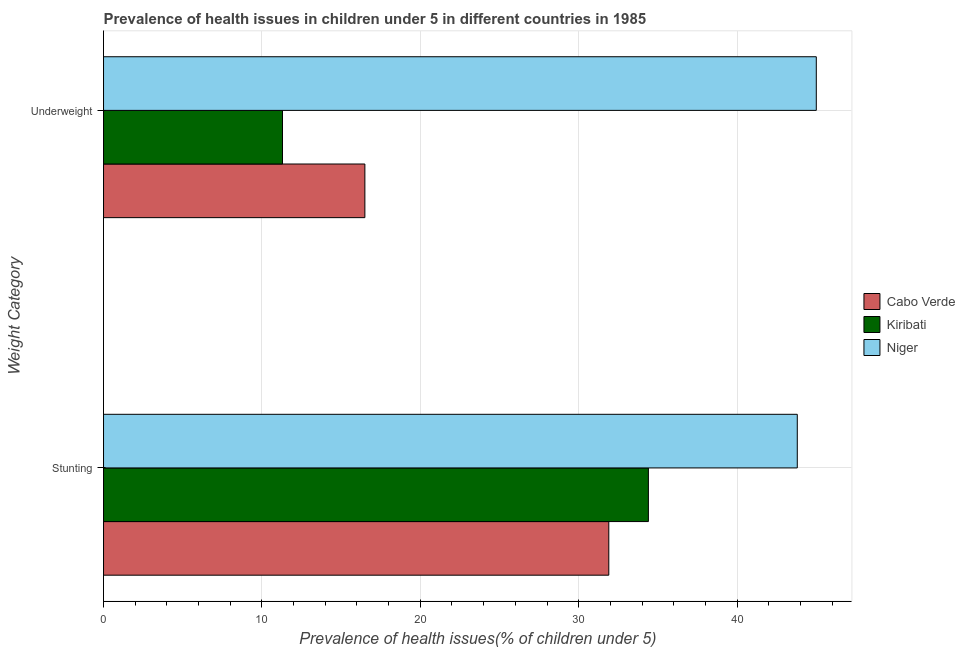How many different coloured bars are there?
Keep it short and to the point. 3. Are the number of bars per tick equal to the number of legend labels?
Your answer should be very brief. Yes. What is the label of the 1st group of bars from the top?
Offer a terse response. Underweight. What is the percentage of stunted children in Niger?
Ensure brevity in your answer.  43.8. Across all countries, what is the minimum percentage of underweight children?
Make the answer very short. 11.3. In which country was the percentage of underweight children maximum?
Ensure brevity in your answer.  Niger. In which country was the percentage of underweight children minimum?
Your response must be concise. Kiribati. What is the total percentage of stunted children in the graph?
Offer a very short reply. 110.1. What is the difference between the percentage of stunted children in Niger and the percentage of underweight children in Cabo Verde?
Your response must be concise. 27.3. What is the average percentage of stunted children per country?
Provide a short and direct response. 36.7. What is the difference between the percentage of underweight children and percentage of stunted children in Niger?
Make the answer very short. 1.2. What is the ratio of the percentage of underweight children in Cabo Verde to that in Niger?
Ensure brevity in your answer.  0.37. In how many countries, is the percentage of stunted children greater than the average percentage of stunted children taken over all countries?
Make the answer very short. 1. What does the 3rd bar from the top in Underweight represents?
Keep it short and to the point. Cabo Verde. What does the 2nd bar from the bottom in Underweight represents?
Offer a terse response. Kiribati. How many bars are there?
Offer a terse response. 6. Does the graph contain grids?
Provide a short and direct response. Yes. Where does the legend appear in the graph?
Your response must be concise. Center right. How many legend labels are there?
Offer a very short reply. 3. How are the legend labels stacked?
Offer a very short reply. Vertical. What is the title of the graph?
Ensure brevity in your answer.  Prevalence of health issues in children under 5 in different countries in 1985. What is the label or title of the X-axis?
Offer a very short reply. Prevalence of health issues(% of children under 5). What is the label or title of the Y-axis?
Provide a succinct answer. Weight Category. What is the Prevalence of health issues(% of children under 5) in Cabo Verde in Stunting?
Keep it short and to the point. 31.9. What is the Prevalence of health issues(% of children under 5) of Kiribati in Stunting?
Give a very brief answer. 34.4. What is the Prevalence of health issues(% of children under 5) in Niger in Stunting?
Your answer should be very brief. 43.8. What is the Prevalence of health issues(% of children under 5) in Kiribati in Underweight?
Your response must be concise. 11.3. What is the Prevalence of health issues(% of children under 5) of Niger in Underweight?
Make the answer very short. 45. Across all Weight Category, what is the maximum Prevalence of health issues(% of children under 5) of Cabo Verde?
Provide a short and direct response. 31.9. Across all Weight Category, what is the maximum Prevalence of health issues(% of children under 5) in Kiribati?
Give a very brief answer. 34.4. Across all Weight Category, what is the maximum Prevalence of health issues(% of children under 5) of Niger?
Provide a short and direct response. 45. Across all Weight Category, what is the minimum Prevalence of health issues(% of children under 5) in Cabo Verde?
Make the answer very short. 16.5. Across all Weight Category, what is the minimum Prevalence of health issues(% of children under 5) of Kiribati?
Provide a short and direct response. 11.3. Across all Weight Category, what is the minimum Prevalence of health issues(% of children under 5) of Niger?
Ensure brevity in your answer.  43.8. What is the total Prevalence of health issues(% of children under 5) in Cabo Verde in the graph?
Make the answer very short. 48.4. What is the total Prevalence of health issues(% of children under 5) in Kiribati in the graph?
Offer a terse response. 45.7. What is the total Prevalence of health issues(% of children under 5) in Niger in the graph?
Your response must be concise. 88.8. What is the difference between the Prevalence of health issues(% of children under 5) in Kiribati in Stunting and that in Underweight?
Offer a terse response. 23.1. What is the difference between the Prevalence of health issues(% of children under 5) of Cabo Verde in Stunting and the Prevalence of health issues(% of children under 5) of Kiribati in Underweight?
Make the answer very short. 20.6. What is the difference between the Prevalence of health issues(% of children under 5) in Cabo Verde in Stunting and the Prevalence of health issues(% of children under 5) in Niger in Underweight?
Provide a short and direct response. -13.1. What is the difference between the Prevalence of health issues(% of children under 5) in Kiribati in Stunting and the Prevalence of health issues(% of children under 5) in Niger in Underweight?
Provide a short and direct response. -10.6. What is the average Prevalence of health issues(% of children under 5) of Cabo Verde per Weight Category?
Offer a very short reply. 24.2. What is the average Prevalence of health issues(% of children under 5) of Kiribati per Weight Category?
Offer a very short reply. 22.85. What is the average Prevalence of health issues(% of children under 5) of Niger per Weight Category?
Your answer should be very brief. 44.4. What is the difference between the Prevalence of health issues(% of children under 5) of Cabo Verde and Prevalence of health issues(% of children under 5) of Niger in Stunting?
Your answer should be compact. -11.9. What is the difference between the Prevalence of health issues(% of children under 5) in Kiribati and Prevalence of health issues(% of children under 5) in Niger in Stunting?
Keep it short and to the point. -9.4. What is the difference between the Prevalence of health issues(% of children under 5) in Cabo Verde and Prevalence of health issues(% of children under 5) in Kiribati in Underweight?
Offer a terse response. 5.2. What is the difference between the Prevalence of health issues(% of children under 5) in Cabo Verde and Prevalence of health issues(% of children under 5) in Niger in Underweight?
Keep it short and to the point. -28.5. What is the difference between the Prevalence of health issues(% of children under 5) of Kiribati and Prevalence of health issues(% of children under 5) of Niger in Underweight?
Make the answer very short. -33.7. What is the ratio of the Prevalence of health issues(% of children under 5) in Cabo Verde in Stunting to that in Underweight?
Ensure brevity in your answer.  1.93. What is the ratio of the Prevalence of health issues(% of children under 5) of Kiribati in Stunting to that in Underweight?
Provide a short and direct response. 3.04. What is the ratio of the Prevalence of health issues(% of children under 5) of Niger in Stunting to that in Underweight?
Offer a terse response. 0.97. What is the difference between the highest and the second highest Prevalence of health issues(% of children under 5) in Cabo Verde?
Provide a short and direct response. 15.4. What is the difference between the highest and the second highest Prevalence of health issues(% of children under 5) of Kiribati?
Offer a very short reply. 23.1. What is the difference between the highest and the second highest Prevalence of health issues(% of children under 5) in Niger?
Provide a succinct answer. 1.2. What is the difference between the highest and the lowest Prevalence of health issues(% of children under 5) in Cabo Verde?
Provide a succinct answer. 15.4. What is the difference between the highest and the lowest Prevalence of health issues(% of children under 5) in Kiribati?
Your response must be concise. 23.1. What is the difference between the highest and the lowest Prevalence of health issues(% of children under 5) in Niger?
Provide a short and direct response. 1.2. 